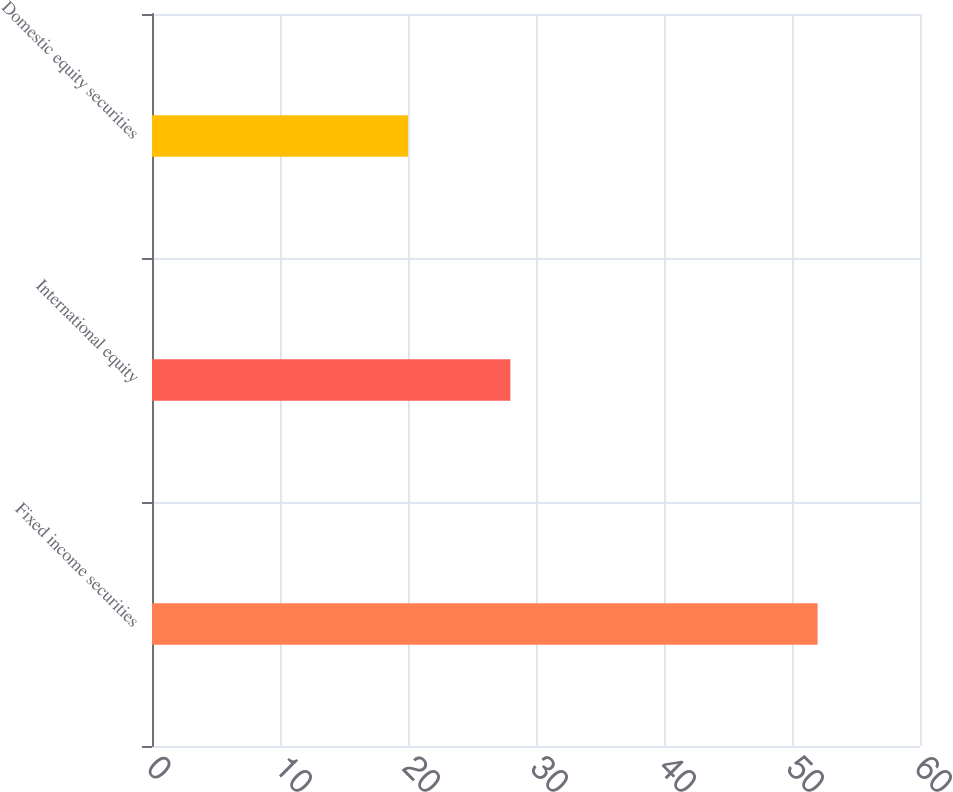Convert chart to OTSL. <chart><loc_0><loc_0><loc_500><loc_500><bar_chart><fcel>Fixed income securities<fcel>International equity<fcel>Domestic equity securities<nl><fcel>52<fcel>28<fcel>20<nl></chart> 